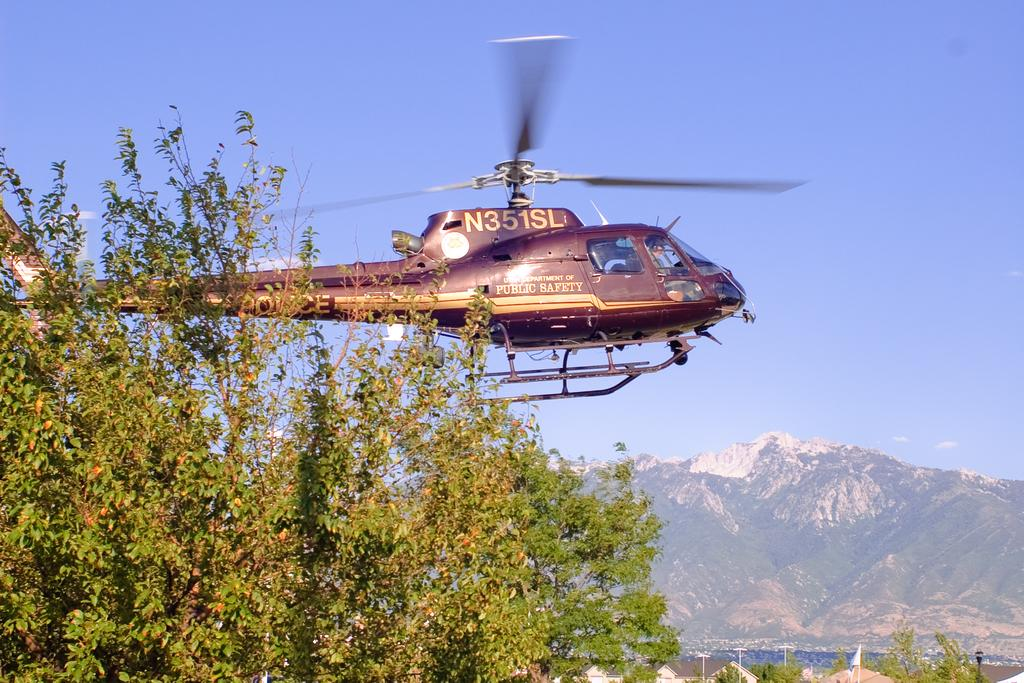Provide a one-sentence caption for the provided image. a helicopter with the letters 'n351sl' on the top of it. 